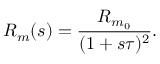<formula> <loc_0><loc_0><loc_500><loc_500>R _ { m } ( s ) = \frac { R _ { m _ { 0 } } } { ( 1 + s \tau ) ^ { 2 } } .</formula> 